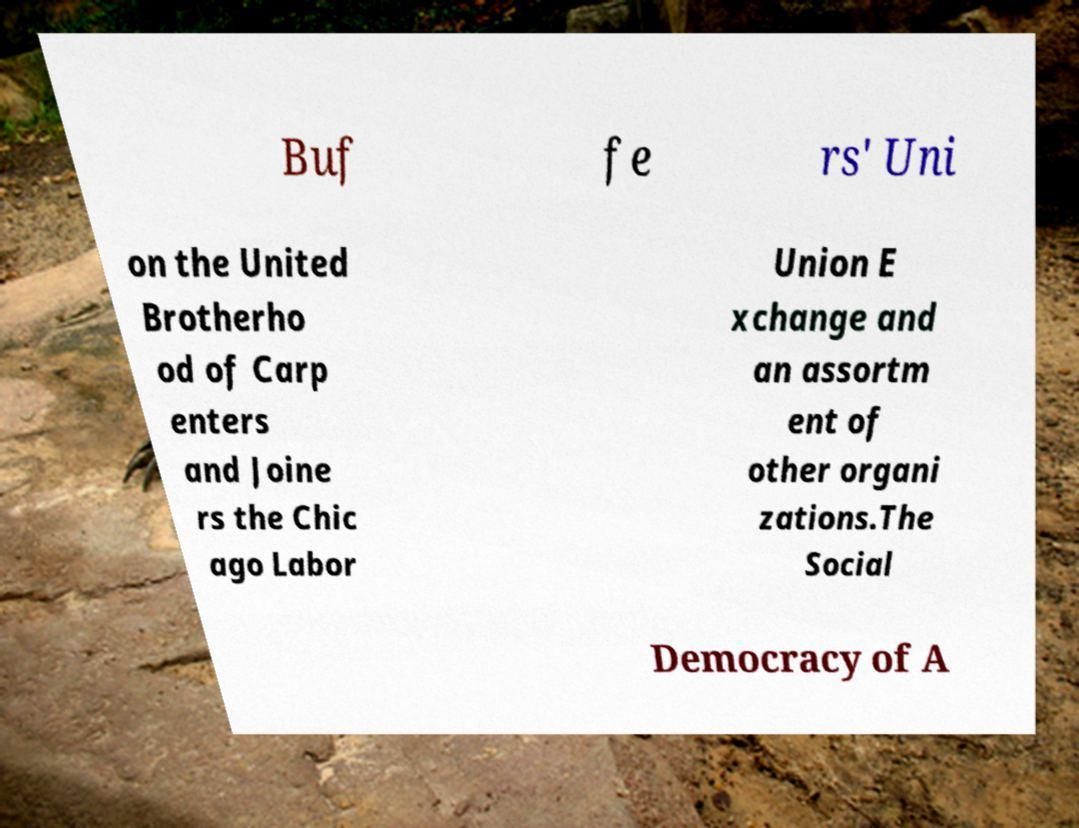Please identify and transcribe the text found in this image. Buf fe rs' Uni on the United Brotherho od of Carp enters and Joine rs the Chic ago Labor Union E xchange and an assortm ent of other organi zations.The Social Democracy of A 